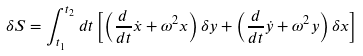<formula> <loc_0><loc_0><loc_500><loc_500>\delta S = \int ^ { t _ { 2 } } _ { t _ { 1 } } d t \left [ \left ( \frac { d } { d t } \dot { x } + \omega ^ { 2 } x \right ) \delta y + \left ( \frac { d } { d t } \dot { y } + \omega ^ { 2 } y \right ) \delta x \right ]</formula> 